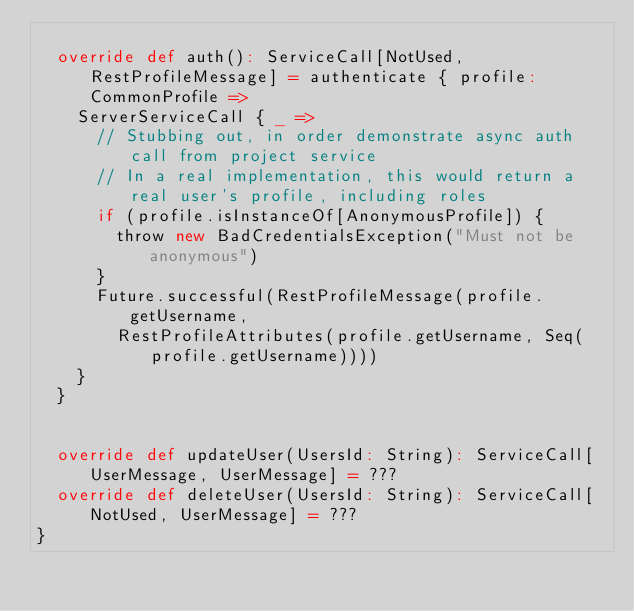Convert code to text. <code><loc_0><loc_0><loc_500><loc_500><_Scala_>
  override def auth(): ServiceCall[NotUsed, RestProfileMessage] = authenticate { profile: CommonProfile =>
    ServerServiceCall { _ =>
      // Stubbing out, in order demonstrate async auth call from project service
      // In a real implementation, this would return a real user's profile, including roles
      if (profile.isInstanceOf[AnonymousProfile]) {
        throw new BadCredentialsException("Must not be anonymous")
      }
      Future.successful(RestProfileMessage(profile.getUsername,
        RestProfileAttributes(profile.getUsername, Seq(profile.getUsername))))
    }
  }


  override def updateUser(UsersId: String): ServiceCall[UserMessage, UserMessage] = ???
  override def deleteUser(UsersId: String): ServiceCall[NotUsed, UserMessage] = ???
}

</code> 